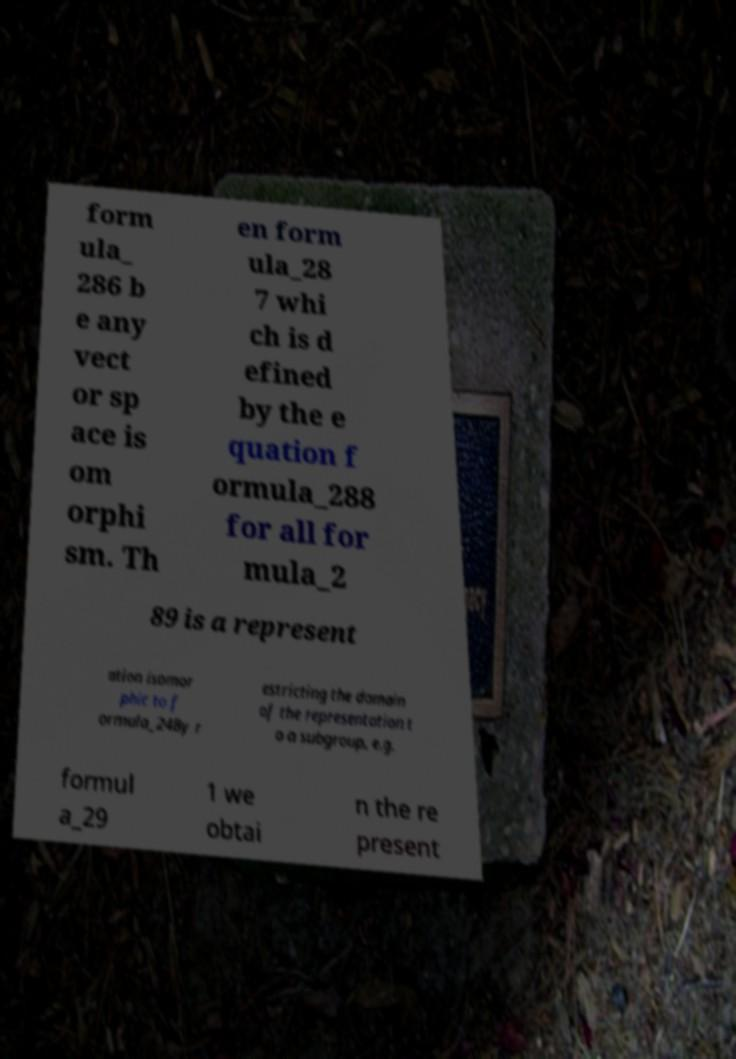What messages or text are displayed in this image? I need them in a readable, typed format. form ula_ 286 b e any vect or sp ace is om orphi sm. Th en form ula_28 7 whi ch is d efined by the e quation f ormula_288 for all for mula_2 89 is a represent ation isomor phic to f ormula_24By r estricting the domain of the representation t o a subgroup, e.g. formul a_29 1 we obtai n the re present 